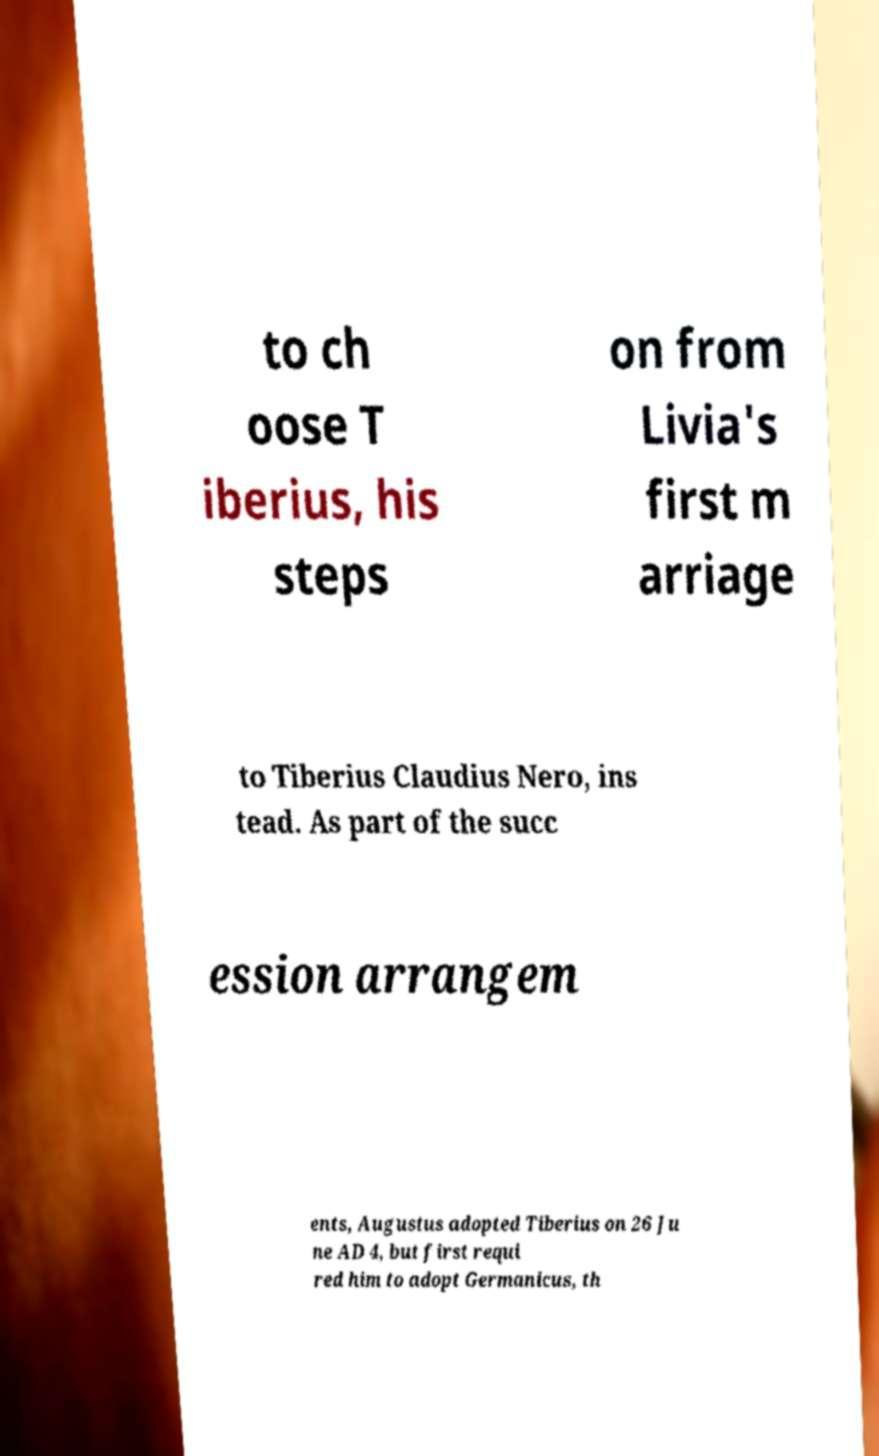For documentation purposes, I need the text within this image transcribed. Could you provide that? to ch oose T iberius, his steps on from Livia's first m arriage to Tiberius Claudius Nero, ins tead. As part of the succ ession arrangem ents, Augustus adopted Tiberius on 26 Ju ne AD 4, but first requi red him to adopt Germanicus, th 